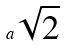Convert formula to latex. <formula><loc_0><loc_0><loc_500><loc_500>a \sqrt { 2 }</formula> 